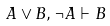<formula> <loc_0><loc_0><loc_500><loc_500>A \vee B , \neg A \vdash B</formula> 